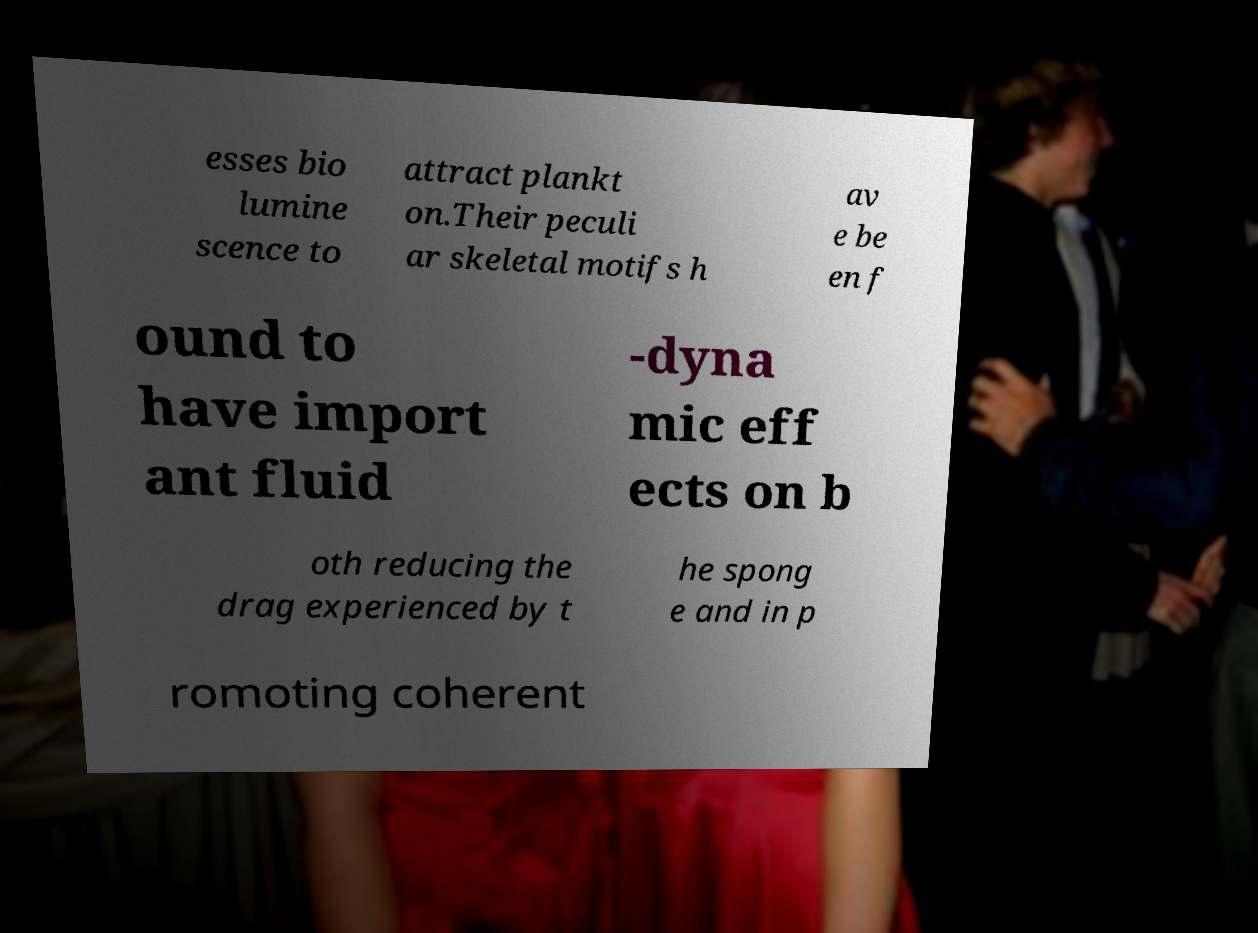Can you read and provide the text displayed in the image?This photo seems to have some interesting text. Can you extract and type it out for me? esses bio lumine scence to attract plankt on.Their peculi ar skeletal motifs h av e be en f ound to have import ant fluid -dyna mic eff ects on b oth reducing the drag experienced by t he spong e and in p romoting coherent 